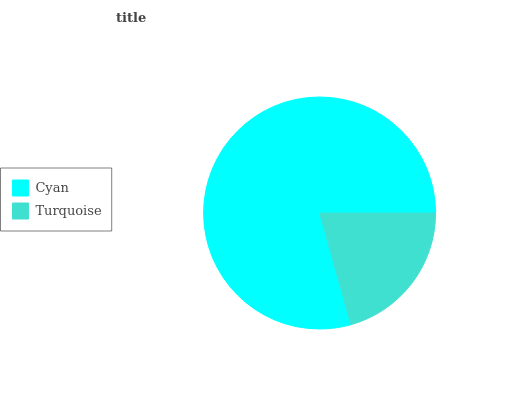Is Turquoise the minimum?
Answer yes or no. Yes. Is Cyan the maximum?
Answer yes or no. Yes. Is Turquoise the maximum?
Answer yes or no. No. Is Cyan greater than Turquoise?
Answer yes or no. Yes. Is Turquoise less than Cyan?
Answer yes or no. Yes. Is Turquoise greater than Cyan?
Answer yes or no. No. Is Cyan less than Turquoise?
Answer yes or no. No. Is Cyan the high median?
Answer yes or no. Yes. Is Turquoise the low median?
Answer yes or no. Yes. Is Turquoise the high median?
Answer yes or no. No. Is Cyan the low median?
Answer yes or no. No. 